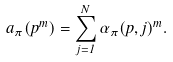<formula> <loc_0><loc_0><loc_500><loc_500>a _ { \pi } ( p ^ { m } ) = \sum _ { j = 1 } ^ { N } \alpha _ { \pi } ( p , j ) ^ { m } .</formula> 